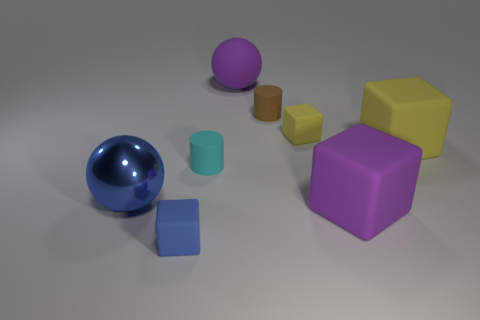There is a large object that is the same color as the big matte sphere; what is it made of?
Give a very brief answer. Rubber. The purple matte cube has what size?
Provide a short and direct response. Large. There is a block that is the same size as the blue matte thing; what is its material?
Give a very brief answer. Rubber. What is the color of the big ball on the right side of the large blue ball?
Give a very brief answer. Purple. What number of large shiny spheres are there?
Your answer should be very brief. 1. There is a rubber cylinder to the left of the large ball that is behind the large metallic thing; is there a brown rubber thing that is on the right side of it?
Keep it short and to the point. Yes. The brown object that is the same size as the cyan cylinder is what shape?
Ensure brevity in your answer.  Cylinder. What is the material of the tiny cyan object?
Keep it short and to the point. Rubber. How many other things are there of the same material as the large yellow thing?
Your response must be concise. 6. There is a matte object that is behind the blue cube and in front of the cyan cylinder; what size is it?
Offer a terse response. Large. 